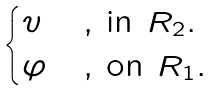<formula> <loc_0><loc_0><loc_500><loc_500>\begin{cases} v & \text {, in $R_{2}.$} \\ \varphi & \text {, on $R_{1}.$} \end{cases}</formula> 